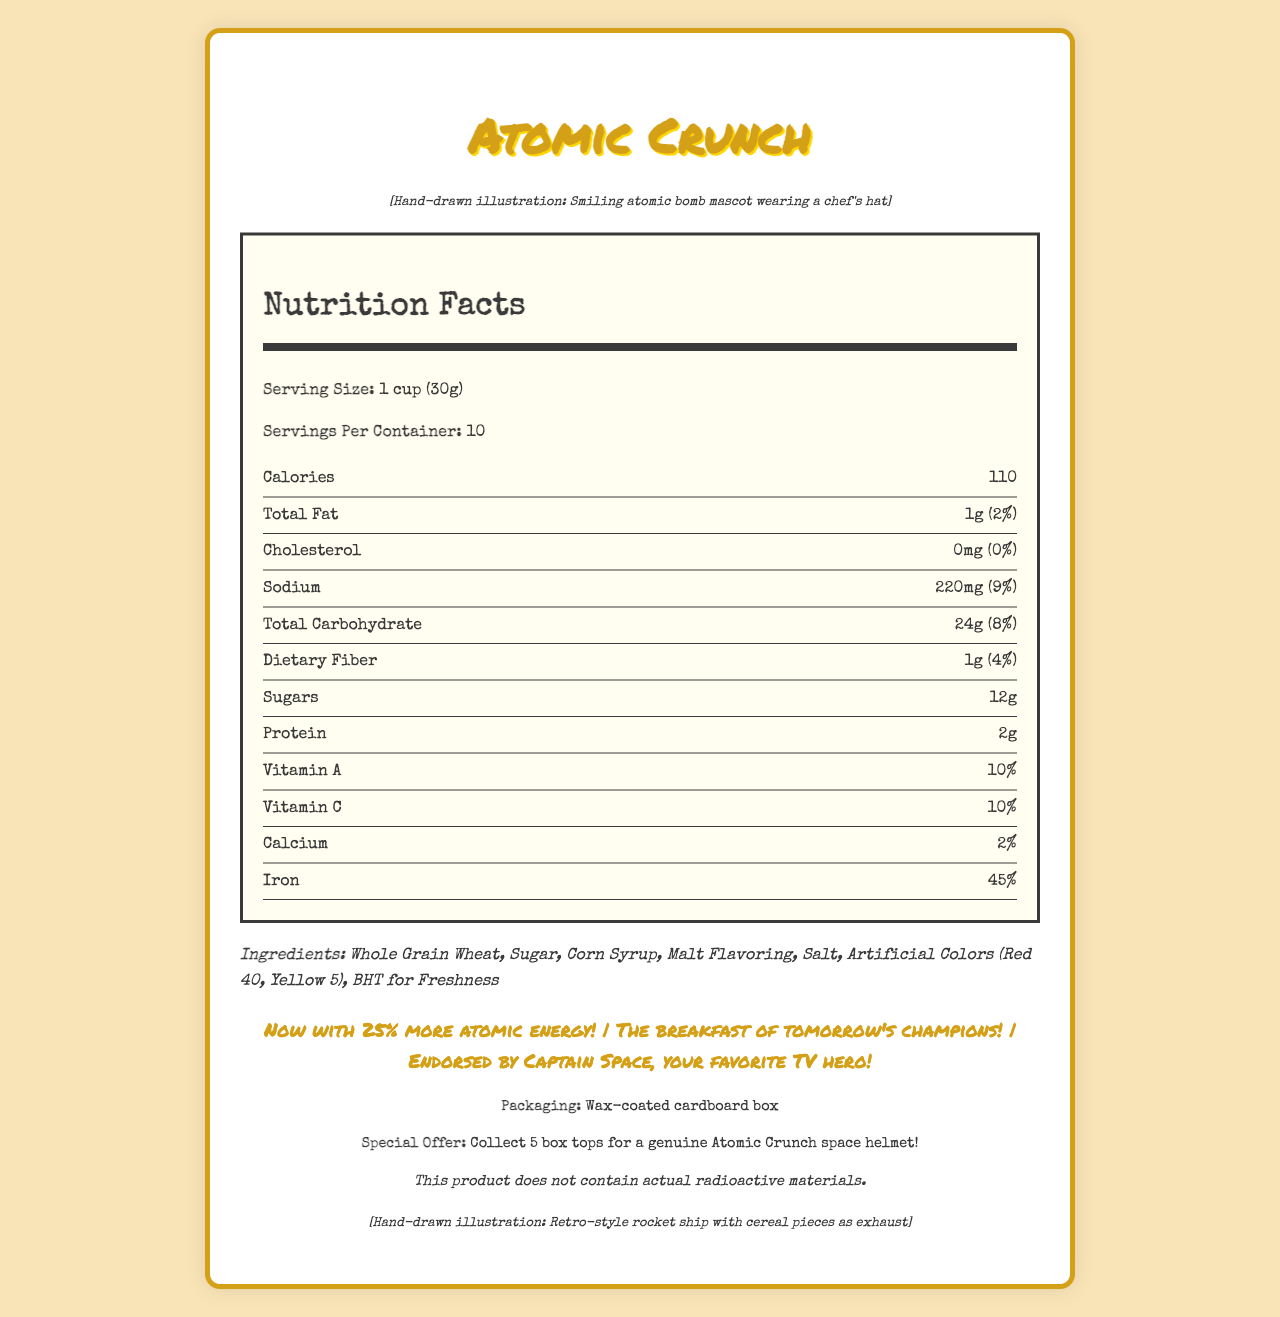what is the serving size? The document specifies the serving size as "1 cup (30g)" under the Nutrition Facts section.
Answer: 1 cup (30g) how many servings are in the container? The document states there are "10" servings per container.
Answer: 10 how many calories are in one serving? The nutrition facts section lists "Calories" as 110 per serving.
Answer: 110 what is the total amount of fat per serving? The Total Fat content per serving is listed as "1g".
Answer: 1g how much sodium is in a serving of this cereal? The Sodium content per serving is given as "220mg".
Answer: 220mg what percent of daily iron is provided in one serving? The document states that one serving provides "45%" of the daily iron intake.
Answer: 45% what are the main ingredients? The ingredients are listed in the document under the Ingredients section.
Answer: Whole Grain Wheat, Sugar, Corn Syrup, Malt Flavoring, Salt, Artificial Colors (Red 40, Yellow 5), BHT for Freshness what is the mascot shown on the top left corner? The hand-drawn illustration description for the mascot is given as "Smiling atomic bomb mascot wearing a chef's hat" in the top left corner.
Answer: Smiling atomic bomb mascot wearing a chef's hat what is the material of the packaging? The document specifies the packaging material as "Wax-coated cardboard box" under Additional Info.
Answer: Wax-coated cardboard box what is the special offer mentioned in the document? The promotional offer is mentioned under Additional Info as "Collect 5 box tops for a genuine Atomic Crunch space helmet!".
Answer: Collect 5 box tops for a genuine Atomic Crunch space helmet! how much sugar is in each serving of the cereal? The document lists "Sugars" as 12g per serving.
Answer: 12g how much protein is in one serving according to the document? The amount of protein per serving is noted as 2g in the document.
Answer: 2g which nostalgic claim mentions Captain Space? A. Now with 25% more atomic energy! B. Endorsed by Captain Space, your favorite TV hero! C. The breakfast of tomorrow's champions! The claim "Endorsed by Captain Space, your favorite TV hero!" mentions Captain Space, based on the contents listed in the Claims section.
Answer: B which of the following is included in the cereal's ingredients? I. Sugar II. BHT for Freshness III. Corn Flakes A. I only B. I and II only C. I, II, and III Both "Sugar" and "BHT for Freshness" are listed in the ingredients section, but "Corn Flakes" is not included.
Answer: B is there any cholesterol in one serving of the cereal? The cholesterol content per serving is listed as "0mg" with a 0% daily value, indicating no cholesterol.
Answer: No summarize the main idea of this nutrition document The document starts with the cereal's name and contains sections on Nutrition Facts, Ingredients, Claims, and Additional Info. It also visually features two hand-drawn illustrations and nostalgic promotional text.
Answer: The nutrition facts document for Atomic Crunch cereal provides detailed information on the serving size, nutritional content per serving, ingredients, nostalgic claims, additional information about packaging, special offers, and includes hand-drawn illustrations of a mascot and a rocket ship. how much Vitamin D does this cereal provide? The document does not list Vitamin D in the nutritional facts section.
Answer: Not enough information does the cereal contain any actual radioactive materials? The additional info section explicitly states: "This product does not contain actual radioactive materials."
Answer: No 